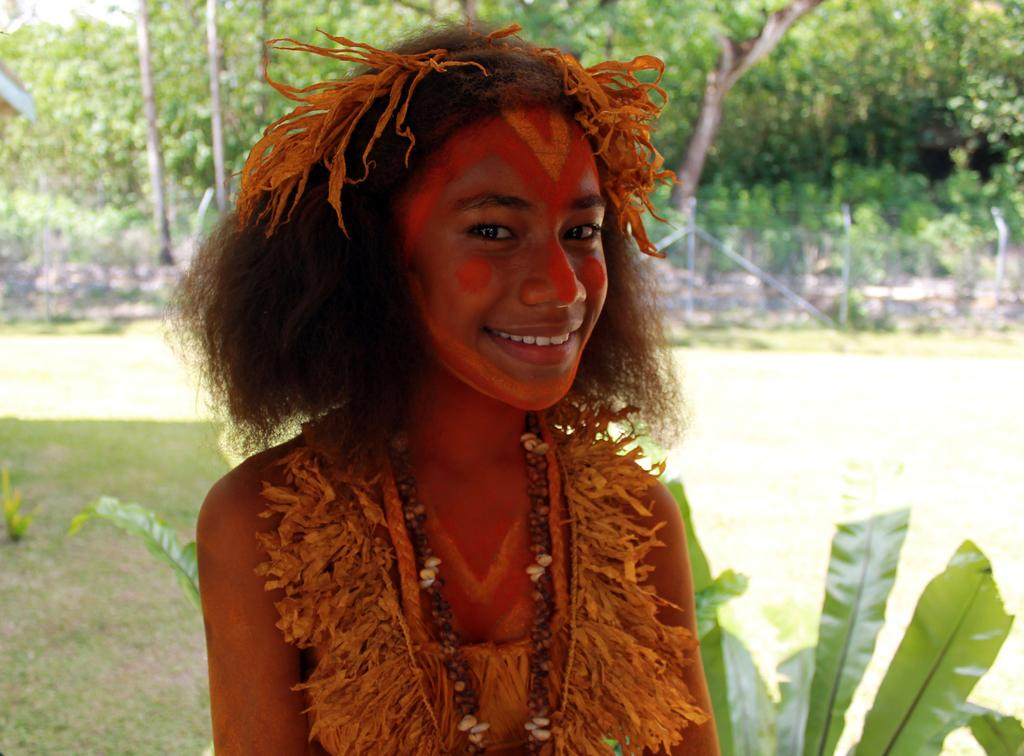What is the main subject of the image? The main subject of the image is a woman. What is the woman wearing in the image? The woman is wearing a costume in the image. What is the woman doing in the image? The woman is watching and smiling in the image. What can be seen in the background of the image? In the background of the image, there is grass, plants, fencing, poles, and trees. What is the weight of the match that the woman is holding in the image? There is no match present in the image, so it is not possible to determine its weight. 